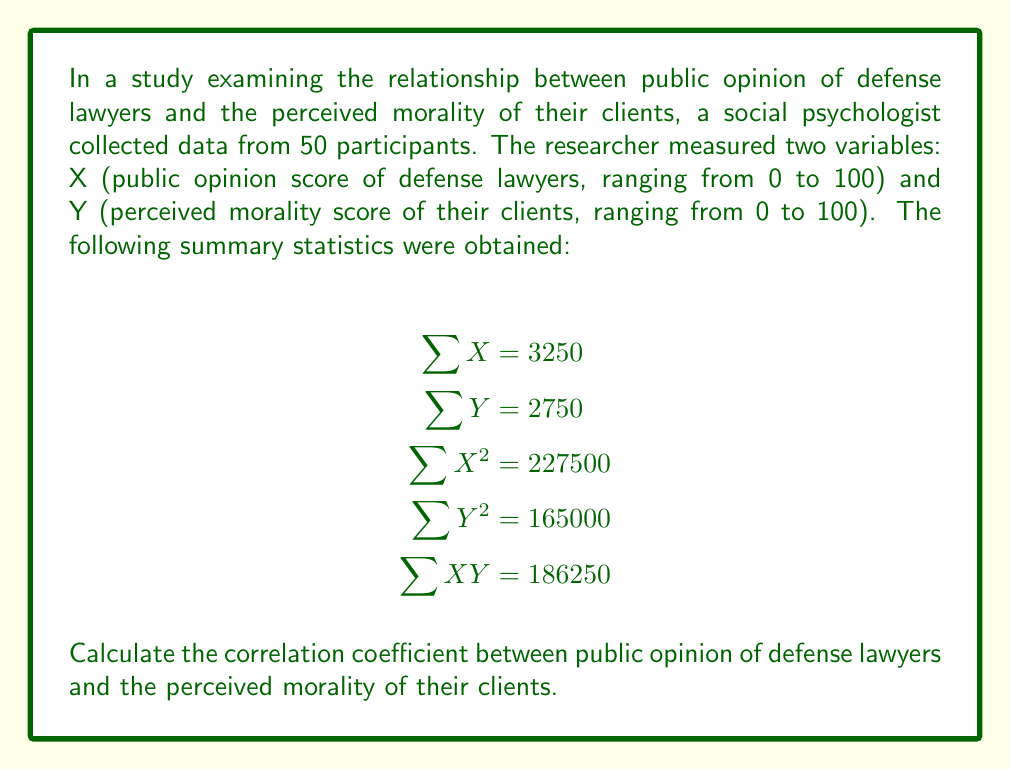Provide a solution to this math problem. To calculate the correlation coefficient (r), we'll use the formula:

$$r = \frac{n\sum XY - (\sum X)(\sum Y)}{\sqrt{[n\sum X^2 - (\sum X)^2][n\sum Y^2 - (\sum Y)^2]}}$$

Where n is the number of participants (50 in this case).

Step 1: Calculate $n\sum XY$
$$n\sum XY = 50 \times 186250 = 9312500$$

Step 2: Calculate $(\sum X)(\sum Y)$
$$(\sum X)(\sum Y) = 3250 \times 2750 = 8937500$$

Step 3: Calculate the numerator
$$9312500 - 8937500 = 375000$$

Step 4: Calculate $n\sum X^2$ and $(\sum X)^2$
$$n\sum X^2 = 50 \times 227500 = 11375000$$
$$(\sum X)^2 = 3250^2 = 10562500$$

Step 5: Calculate $n\sum Y^2$ and $(\sum Y)^2$
$$n\sum Y^2 = 50 \times 165000 = 8250000$$
$$(\sum Y)^2 = 2750^2 = 7562500$$

Step 6: Calculate the denominator
$$\sqrt{(11375000 - 10562500)(8250000 - 7562500)}$$
$$= \sqrt{(812500)(687500)}$$
$$= \sqrt{558593750000}$$
$$= 747390.85$$

Step 7: Calculate the correlation coefficient
$$r = \frac{375000}{747390.85} \approx 0.5017$$
Answer: The correlation coefficient between public opinion of defense lawyers and the perceived morality of their clients is approximately 0.5017. 